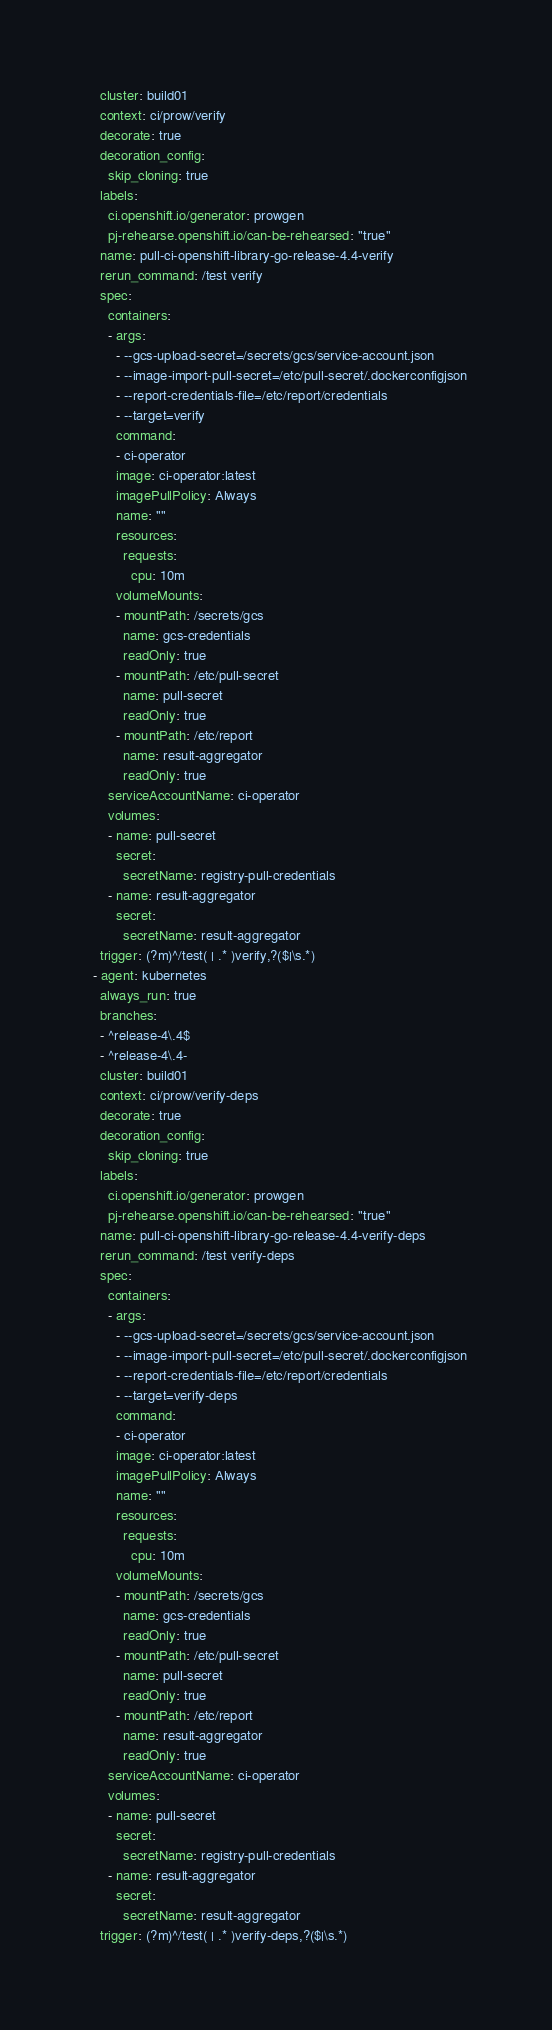<code> <loc_0><loc_0><loc_500><loc_500><_YAML_>    cluster: build01
    context: ci/prow/verify
    decorate: true
    decoration_config:
      skip_cloning: true
    labels:
      ci.openshift.io/generator: prowgen
      pj-rehearse.openshift.io/can-be-rehearsed: "true"
    name: pull-ci-openshift-library-go-release-4.4-verify
    rerun_command: /test verify
    spec:
      containers:
      - args:
        - --gcs-upload-secret=/secrets/gcs/service-account.json
        - --image-import-pull-secret=/etc/pull-secret/.dockerconfigjson
        - --report-credentials-file=/etc/report/credentials
        - --target=verify
        command:
        - ci-operator
        image: ci-operator:latest
        imagePullPolicy: Always
        name: ""
        resources:
          requests:
            cpu: 10m
        volumeMounts:
        - mountPath: /secrets/gcs
          name: gcs-credentials
          readOnly: true
        - mountPath: /etc/pull-secret
          name: pull-secret
          readOnly: true
        - mountPath: /etc/report
          name: result-aggregator
          readOnly: true
      serviceAccountName: ci-operator
      volumes:
      - name: pull-secret
        secret:
          secretName: registry-pull-credentials
      - name: result-aggregator
        secret:
          secretName: result-aggregator
    trigger: (?m)^/test( | .* )verify,?($|\s.*)
  - agent: kubernetes
    always_run: true
    branches:
    - ^release-4\.4$
    - ^release-4\.4-
    cluster: build01
    context: ci/prow/verify-deps
    decorate: true
    decoration_config:
      skip_cloning: true
    labels:
      ci.openshift.io/generator: prowgen
      pj-rehearse.openshift.io/can-be-rehearsed: "true"
    name: pull-ci-openshift-library-go-release-4.4-verify-deps
    rerun_command: /test verify-deps
    spec:
      containers:
      - args:
        - --gcs-upload-secret=/secrets/gcs/service-account.json
        - --image-import-pull-secret=/etc/pull-secret/.dockerconfigjson
        - --report-credentials-file=/etc/report/credentials
        - --target=verify-deps
        command:
        - ci-operator
        image: ci-operator:latest
        imagePullPolicy: Always
        name: ""
        resources:
          requests:
            cpu: 10m
        volumeMounts:
        - mountPath: /secrets/gcs
          name: gcs-credentials
          readOnly: true
        - mountPath: /etc/pull-secret
          name: pull-secret
          readOnly: true
        - mountPath: /etc/report
          name: result-aggregator
          readOnly: true
      serviceAccountName: ci-operator
      volumes:
      - name: pull-secret
        secret:
          secretName: registry-pull-credentials
      - name: result-aggregator
        secret:
          secretName: result-aggregator
    trigger: (?m)^/test( | .* )verify-deps,?($|\s.*)
</code> 